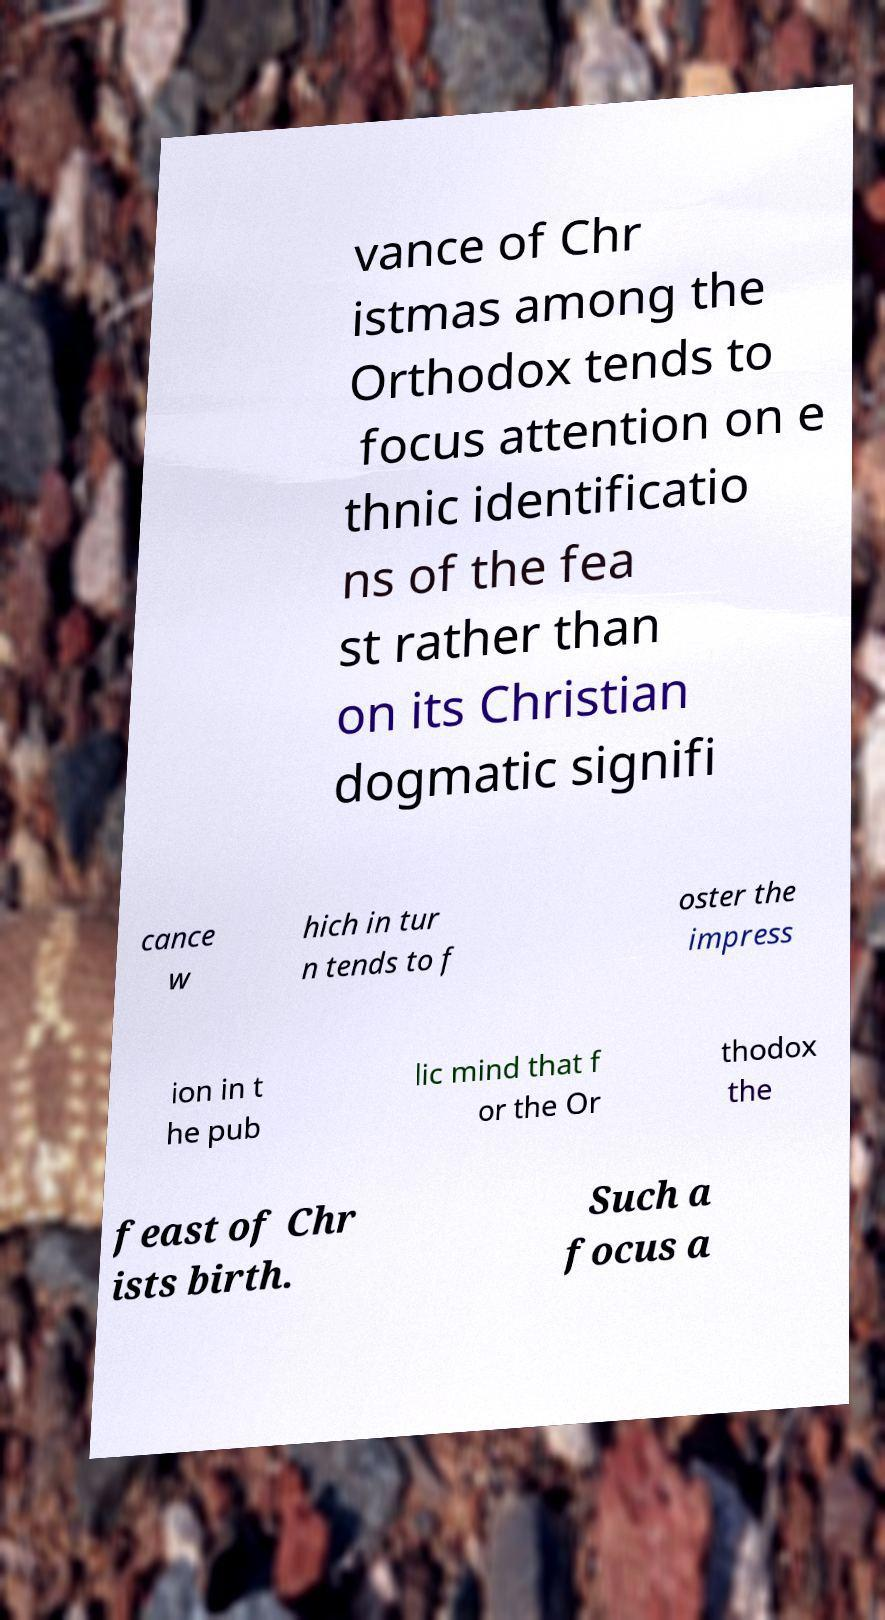Could you assist in decoding the text presented in this image and type it out clearly? vance of Chr istmas among the Orthodox tends to focus attention on e thnic identificatio ns of the fea st rather than on its Christian dogmatic signifi cance w hich in tur n tends to f oster the impress ion in t he pub lic mind that f or the Or thodox the feast of Chr ists birth. Such a focus a 